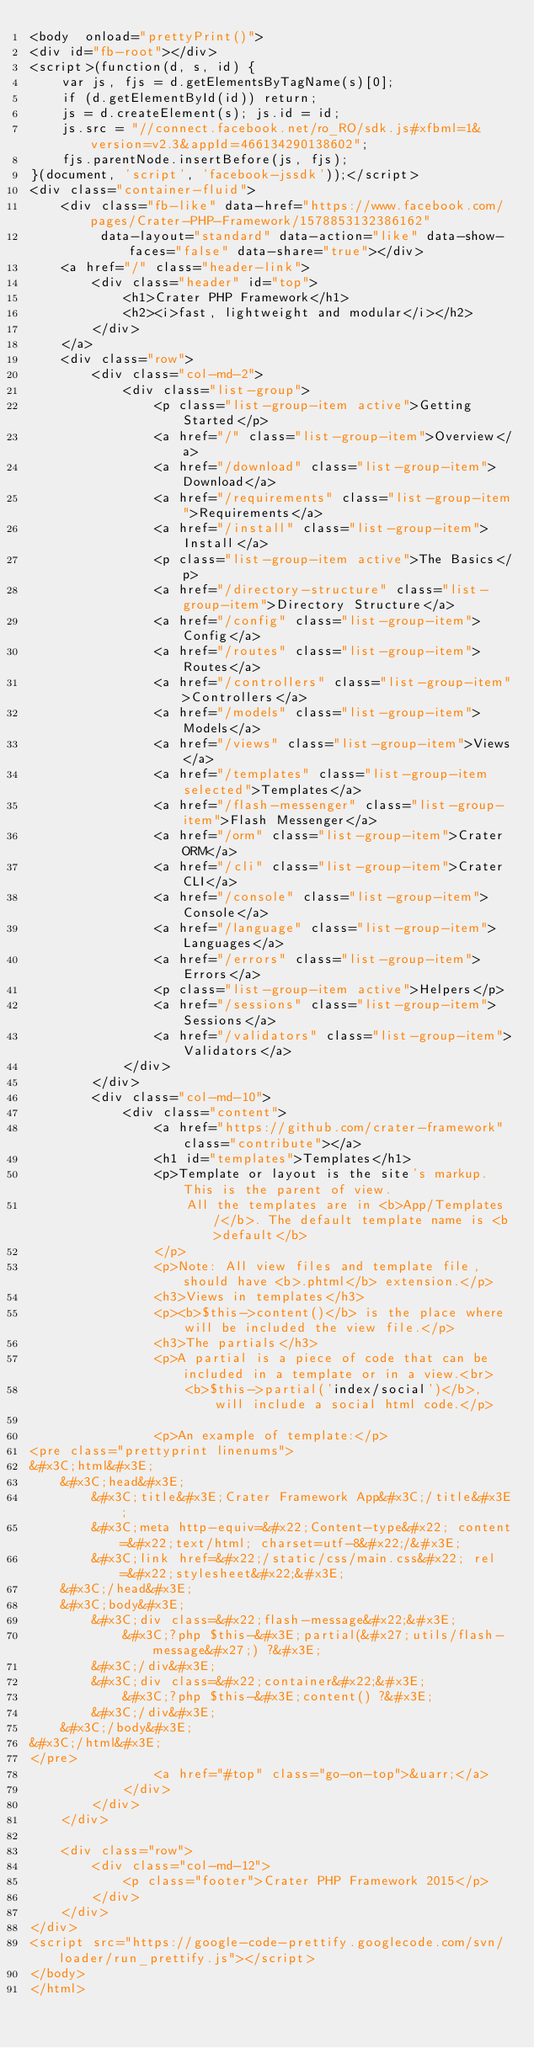Convert code to text. <code><loc_0><loc_0><loc_500><loc_500><_HTML_><body  onload="prettyPrint()">
<div id="fb-root"></div>
<script>(function(d, s, id) {
    var js, fjs = d.getElementsByTagName(s)[0];
    if (d.getElementById(id)) return;
    js = d.createElement(s); js.id = id;
    js.src = "//connect.facebook.net/ro_RO/sdk.js#xfbml=1&version=v2.3&appId=466134290138602";
    fjs.parentNode.insertBefore(js, fjs);
}(document, 'script', 'facebook-jssdk'));</script>
<div class="container-fluid">
    <div class="fb-like" data-href="https://www.facebook.com/pages/Crater-PHP-Framework/1578853132386162"
         data-layout="standard" data-action="like" data-show-faces="false" data-share="true"></div>
    <a href="/" class="header-link">
        <div class="header" id="top">
            <h1>Crater PHP Framework</h1>
            <h2><i>fast, lightweight and modular</i></h2>
        </div>
    </a>
    <div class="row">
        <div class="col-md-2">
            <div class="list-group">
                <p class="list-group-item active">Getting Started</p>
                <a href="/" class="list-group-item">Overview</a>
                <a href="/download" class="list-group-item">Download</a>
                <a href="/requirements" class="list-group-item">Requirements</a>
                <a href="/install" class="list-group-item">Install</a>
                <p class="list-group-item active">The Basics</p>
                <a href="/directory-structure" class="list-group-item">Directory Structure</a>
                <a href="/config" class="list-group-item">Config</a>
                <a href="/routes" class="list-group-item">Routes</a>
                <a href="/controllers" class="list-group-item">Controllers</a>
                <a href="/models" class="list-group-item">Models</a>
                <a href="/views" class="list-group-item">Views</a>
                <a href="/templates" class="list-group-item selected">Templates</a>
                <a href="/flash-messenger" class="list-group-item">Flash Messenger</a>
                <a href="/orm" class="list-group-item">Crater ORM</a>
                <a href="/cli" class="list-group-item">Crater CLI</a>
                <a href="/console" class="list-group-item">Console</a>
                <a href="/language" class="list-group-item">Languages</a>
                <a href="/errors" class="list-group-item">Errors</a>
                <p class="list-group-item active">Helpers</p>
                <a href="/sessions" class="list-group-item">Sessions</a>
                <a href="/validators" class="list-group-item">Validators</a>
            </div>
        </div>
        <div class="col-md-10">
            <div class="content">
                <a href="https://github.com/crater-framework" class="contribute"></a>
                <h1 id="templates">Templates</h1>
                <p>Template or layout is the site's markup. This is the parent of view.
                    All the templates are in <b>App/Templates/</b>. The default template name is <b>default</b>
                </p>
                <p>Note: All view files and template file, should have <b>.phtml</b> extension.</p>
                <h3>Views in templates</h3>
                <p><b>$this->content()</b> is the place where will be included the view file.</p>
                <h3>The partials</h3>
                <p>A partial is a piece of code that can be included in a template or in a view.<br>
                    <b>$this->partial('index/social')</b>, will include a social html code.</p>

                <p>An example of template:</p>
<pre class="prettyprint linenums">
&#x3C;html&#x3E;
    &#x3C;head&#x3E;
        &#x3C;title&#x3E;Crater Framework App&#x3C;/title&#x3E;
        &#x3C;meta http-equiv=&#x22;Content-type&#x22; content=&#x22;text/html; charset=utf-8&#x22;/&#x3E;
        &#x3C;link href=&#x22;/static/css/main.css&#x22; rel=&#x22;stylesheet&#x22;&#x3E;
    &#x3C;/head&#x3E;
    &#x3C;body&#x3E;
        &#x3C;div class=&#x22;flash-message&#x22;&#x3E;
            &#x3C;?php $this-&#x3E;partial(&#x27;utils/flash-message&#x27;) ?&#x3E;
        &#x3C;/div&#x3E;
        &#x3C;div class=&#x22;container&#x22;&#x3E;
            &#x3C;?php $this-&#x3E;content() ?&#x3E;
        &#x3C;/div&#x3E;
    &#x3C;/body&#x3E;
&#x3C;/html&#x3E;
</pre>
                <a href="#top" class="go-on-top">&uarr;</a>
            </div>
        </div>
    </div>

    <div class="row">
        <div class="col-md-12">
            <p class="footer">Crater PHP Framework 2015</p>
        </div>
    </div>
</div>
<script src="https://google-code-prettify.googlecode.com/svn/loader/run_prettify.js"></script>
</body>
</html>

</code> 